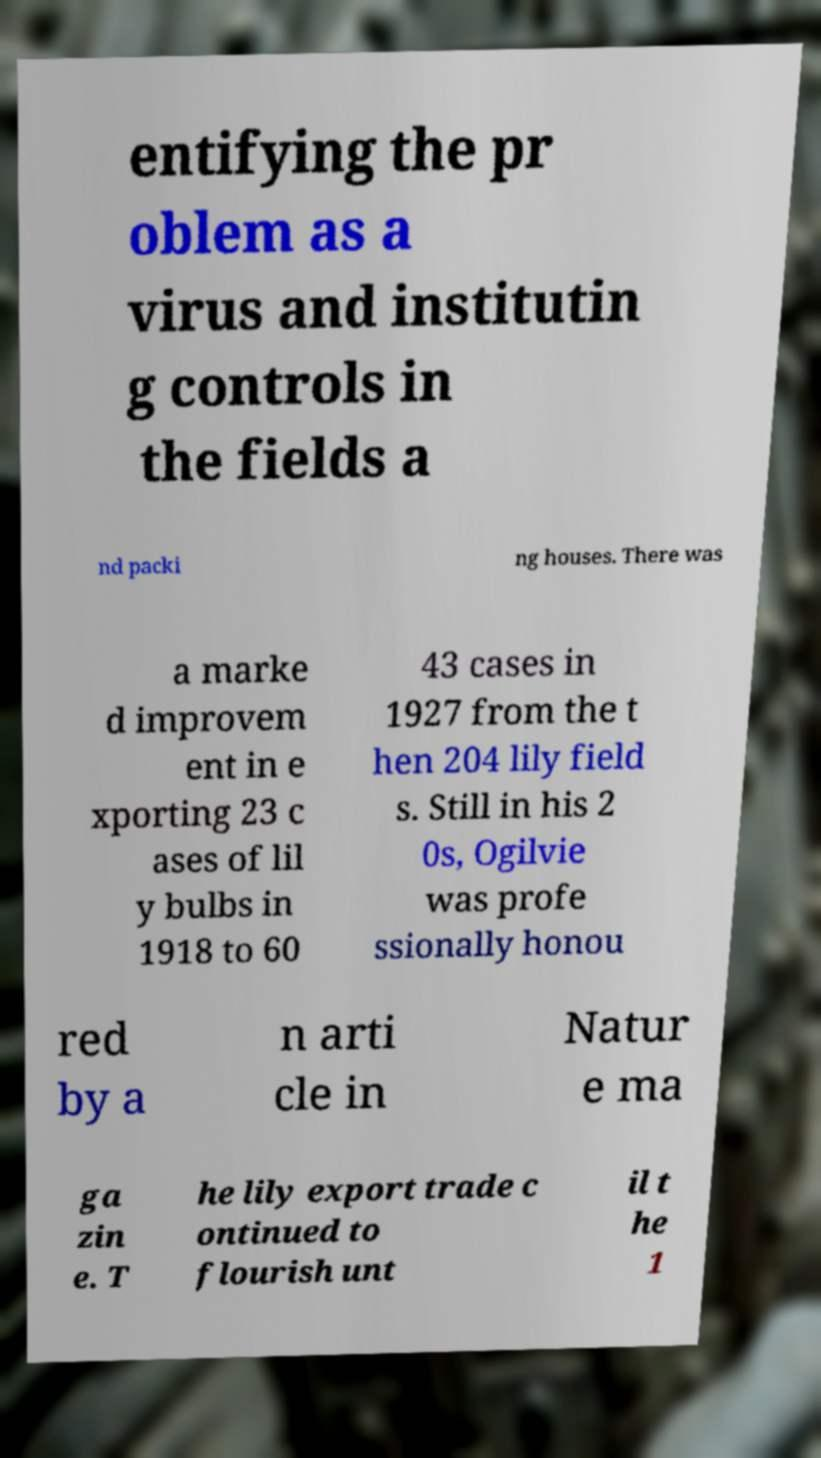Please read and relay the text visible in this image. What does it say? entifying the pr oblem as a virus and institutin g controls in the fields a nd packi ng houses. There was a marke d improvem ent in e xporting 23 c ases of lil y bulbs in 1918 to 60 43 cases in 1927 from the t hen 204 lily field s. Still in his 2 0s, Ogilvie was profe ssionally honou red by a n arti cle in Natur e ma ga zin e. T he lily export trade c ontinued to flourish unt il t he 1 